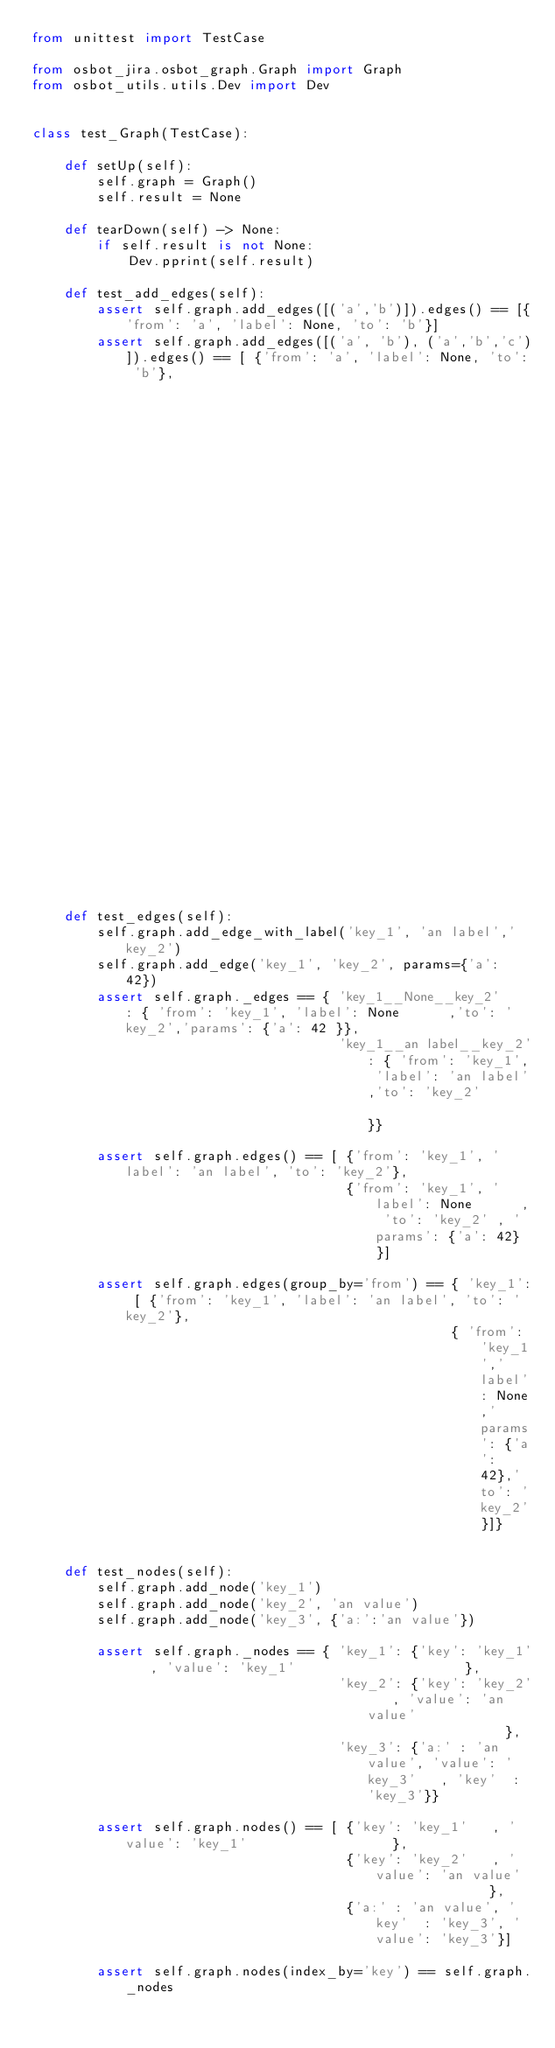<code> <loc_0><loc_0><loc_500><loc_500><_Python_>from unittest import TestCase

from osbot_jira.osbot_graph.Graph import Graph
from osbot_utils.utils.Dev import Dev


class test_Graph(TestCase):

    def setUp(self):
        self.graph = Graph()
        self.result = None

    def tearDown(self) -> None:
        if self.result is not None:
            Dev.pprint(self.result)

    def test_add_edges(self):
        assert self.graph.add_edges([('a','b')]).edges() == [{'from': 'a', 'label': None, 'to': 'b'}]
        assert self.graph.add_edges([('a', 'b'), ('a','b','c')]).edges() == [ {'from': 'a', 'label': None, 'to': 'b'},
                                                                              {'from': 'a', 'label': 'b' , 'to': 'c'}]

    def test_edges(self):
        self.graph.add_edge_with_label('key_1', 'an label','key_2')
        self.graph.add_edge('key_1', 'key_2', params={'a': 42})
        assert self.graph._edges == { 'key_1__None__key_2'    : { 'from': 'key_1', 'label': None      ,'to': 'key_2','params': {'a': 42 }},
                                      'key_1__an label__key_2': { 'from': 'key_1', 'label': 'an label','to': 'key_2'                    }}

        assert self.graph.edges() == [ {'from': 'key_1', 'label': 'an label', 'to': 'key_2'},
                                       {'from': 'key_1', 'label': None      , 'to': 'key_2' , 'params': {'a': 42} }]

        assert self.graph.edges(group_by='from') == { 'key_1': [ {'from': 'key_1', 'label': 'an label', 'to': 'key_2'},
                                                    { 'from': 'key_1','label': None,'params': {'a': 42},'to': 'key_2'}]}


    def test_nodes(self):
        self.graph.add_node('key_1')
        self.graph.add_node('key_2', 'an value')
        self.graph.add_node('key_3', {'a:':'an value'})

        assert self.graph._nodes == { 'key_1': {'key': 'key_1'   , 'value': 'key_1'                     },
                                      'key_2': {'key': 'key_2'   , 'value': 'an value'                  },
                                      'key_3': {'a:' : 'an value', 'value': 'key_3'   , 'key'  : 'key_3'}}

        assert self.graph.nodes() == [ {'key': 'key_1'   , 'value': 'key_1'                  },
                                       {'key': 'key_2'   , 'value': 'an value'               },
                                       {'a:' : 'an value', 'key'  : 'key_3', 'value': 'key_3'}]

        assert self.graph.nodes(index_by='key') == self.graph._nodes



</code> 